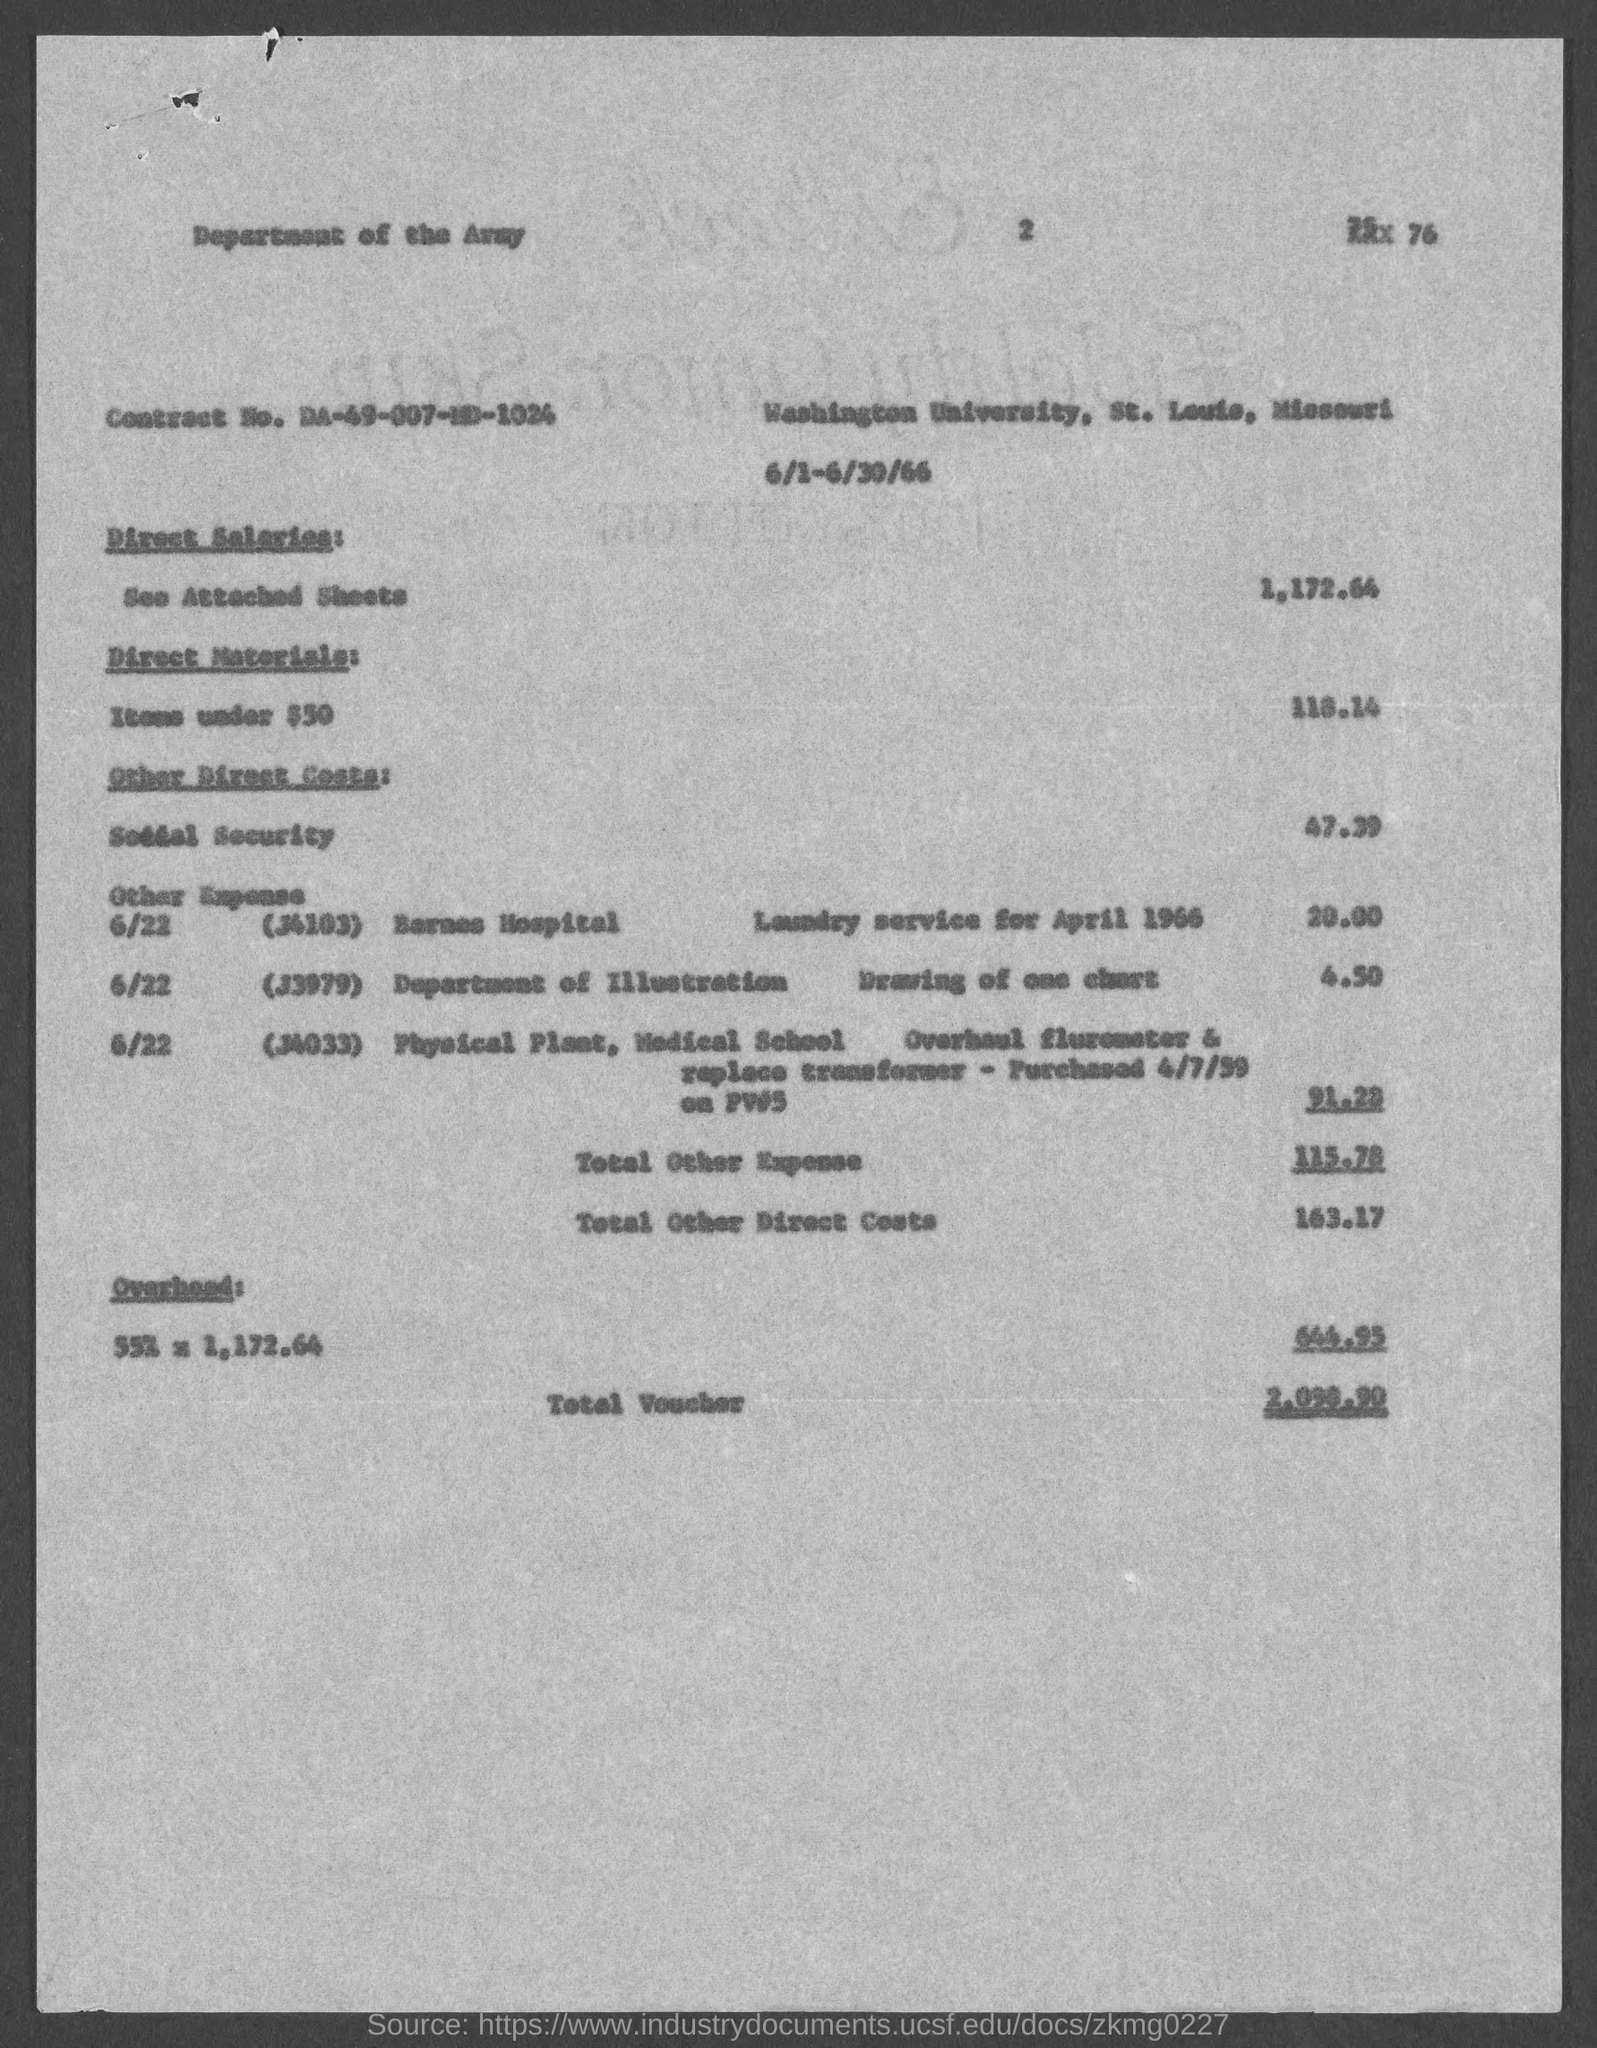What is the Contract No. given in the voucher?
Your answer should be very brief. DA-49-007-MD-1024. What is the direct salaries cost mentioned in the voucher?
Give a very brief answer. 1,172.64. What is the Direct materials cost (Items under $50) given in the voucher?
Give a very brief answer. 118.14. What is the total other direct costs mentioned in the voucher?
Keep it short and to the point. 163.17. What is the overhead cost given in the voucher?
Your answer should be very brief. 644.95. 